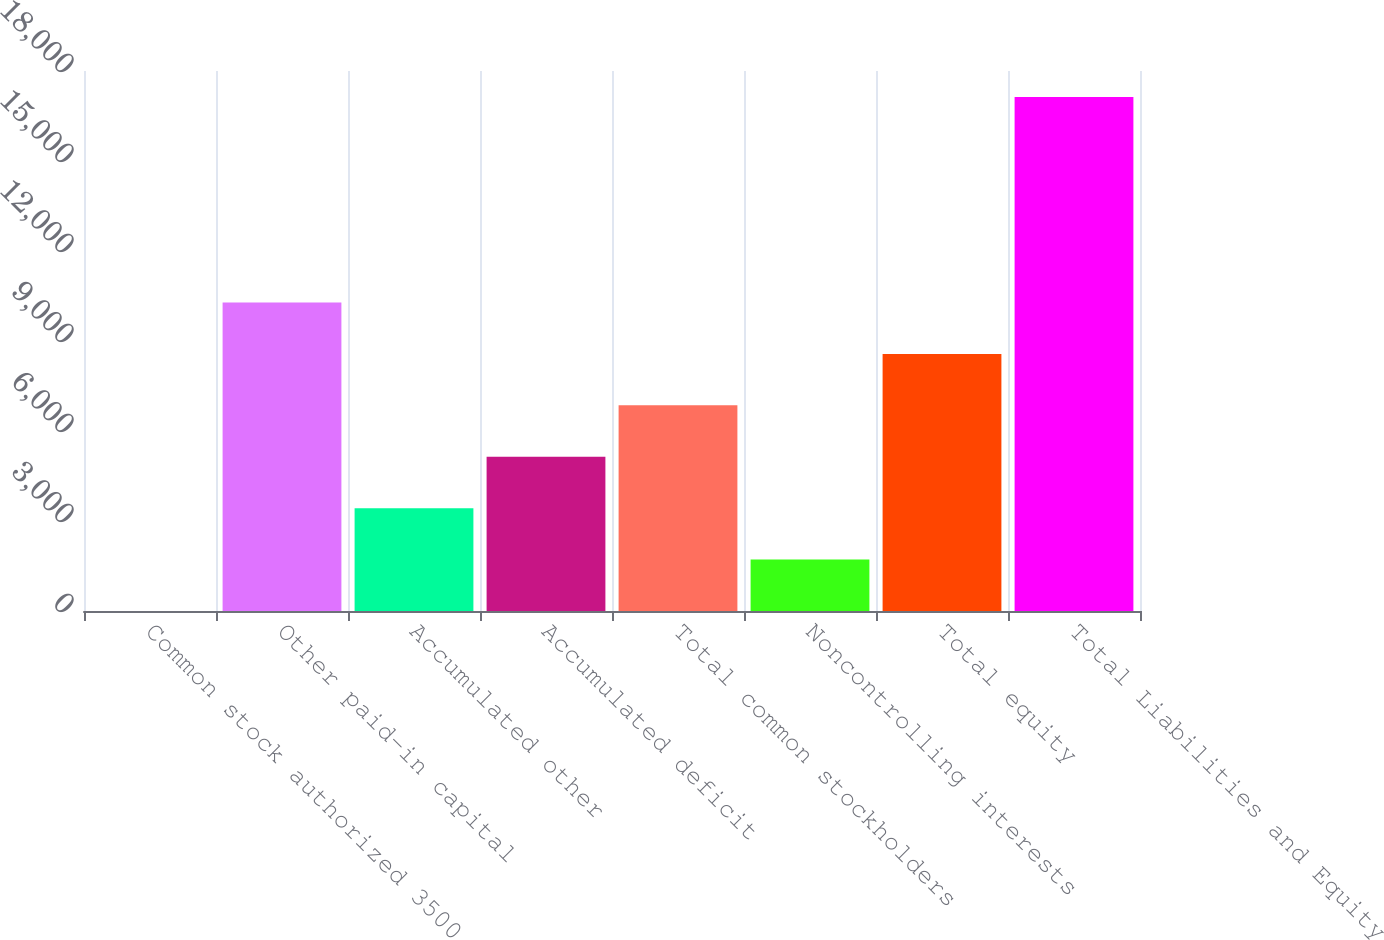Convert chart to OTSL. <chart><loc_0><loc_0><loc_500><loc_500><bar_chart><fcel>Common stock authorized 3500<fcel>Other paid-in capital<fcel>Accumulated other<fcel>Accumulated deficit<fcel>Total common stockholders<fcel>Noncontrolling interests<fcel>Total equity<fcel>Total Liabilities and Equity<nl><fcel>3<fcel>10279.8<fcel>3428.6<fcel>5141.4<fcel>6854.2<fcel>1715.8<fcel>8567<fcel>17131<nl></chart> 